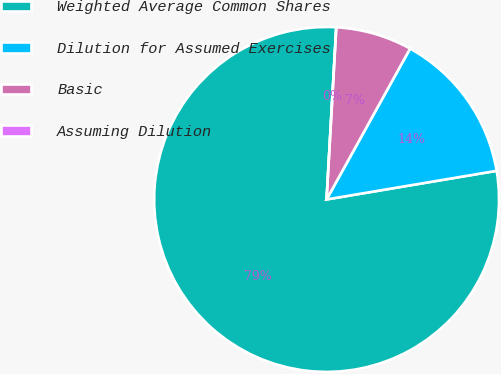Convert chart. <chart><loc_0><loc_0><loc_500><loc_500><pie_chart><fcel>Weighted Average Common Shares<fcel>Dilution for Assumed Exercises<fcel>Basic<fcel>Assuming Dilution<nl><fcel>78.55%<fcel>14.3%<fcel>7.15%<fcel>0.0%<nl></chart> 